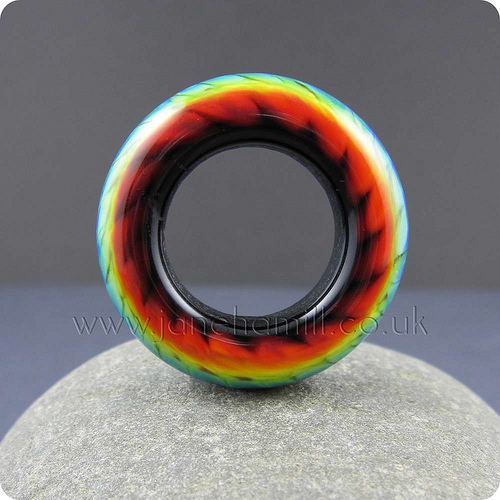<image>
Can you confirm if the ring is on the stone? Yes. Looking at the image, I can see the ring is positioned on top of the stone, with the stone providing support. 